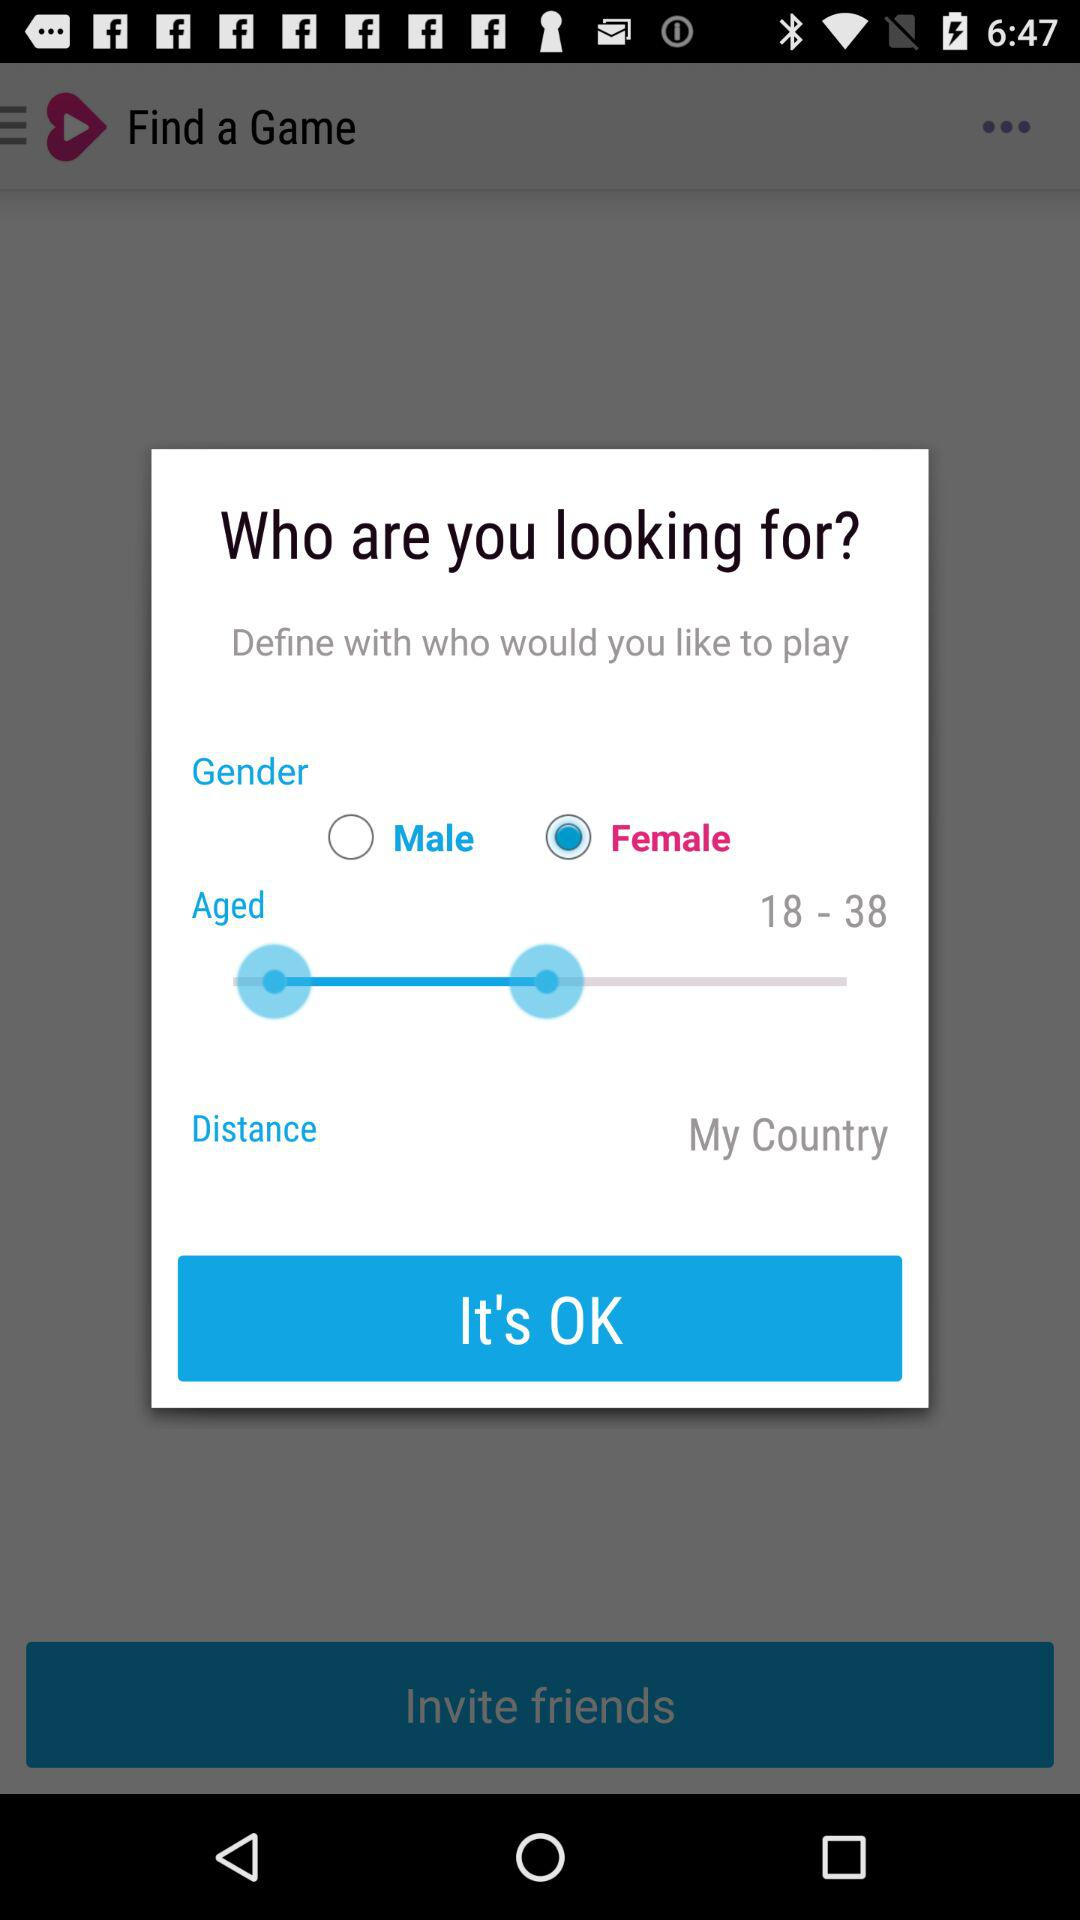What is the selected age range? The selected age range is 18 to 38 years. 